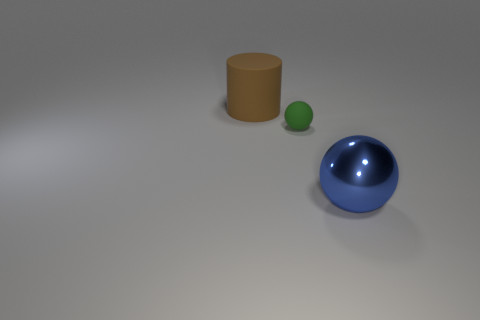Add 2 large brown rubber cylinders. How many objects exist? 5 Subtract all cylinders. How many objects are left? 2 Subtract all green balls. Subtract all blue spheres. How many objects are left? 1 Add 3 blue spheres. How many blue spheres are left? 4 Add 1 large blue shiny balls. How many large blue shiny balls exist? 2 Subtract 0 yellow cubes. How many objects are left? 3 